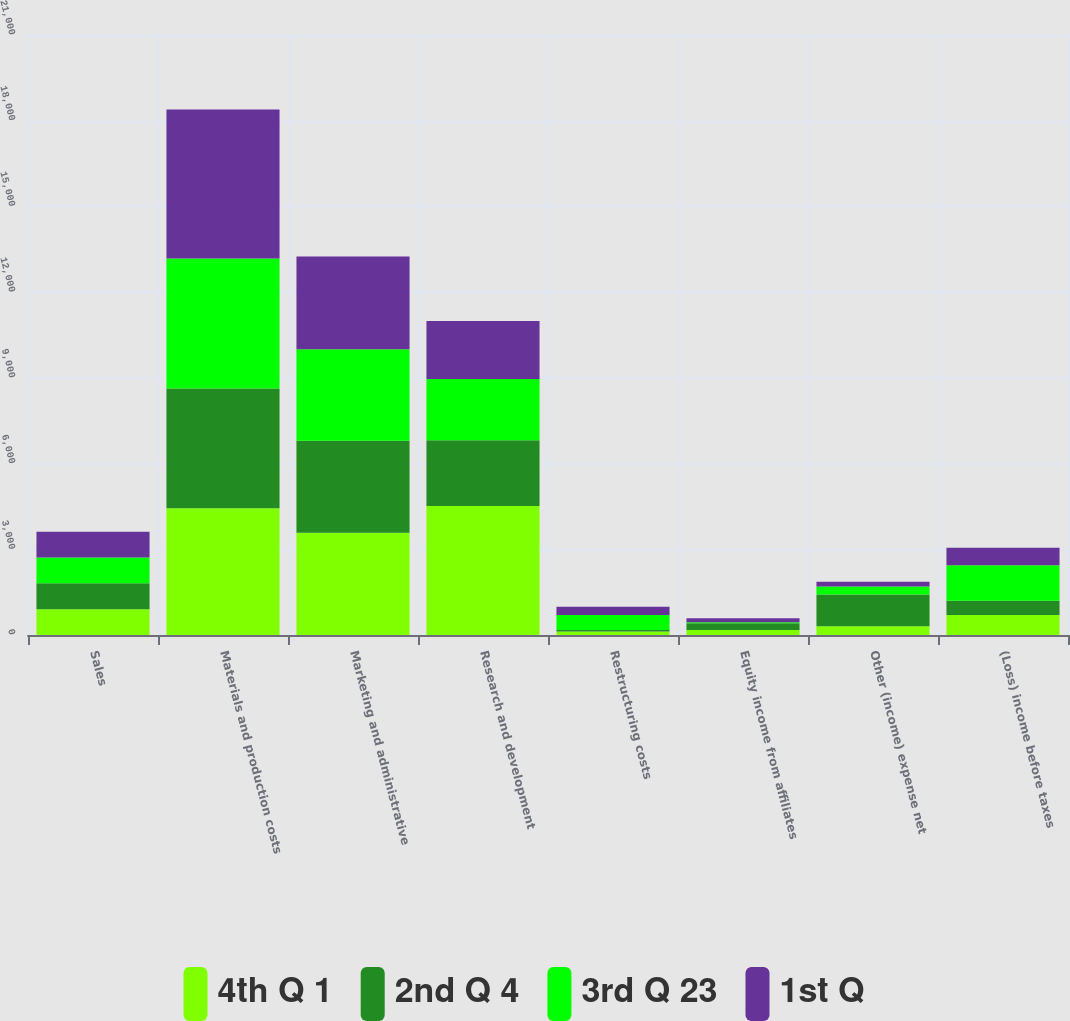<chart> <loc_0><loc_0><loc_500><loc_500><stacked_bar_chart><ecel><fcel>Sales<fcel>Materials and production costs<fcel>Marketing and administrative<fcel>Research and development<fcel>Restructuring costs<fcel>Equity income from affiliates<fcel>Other (income) expense net<fcel>(Loss) income before taxes<nl><fcel>4th Q 1<fcel>904.5<fcel>4440<fcel>3579<fcel>4517<fcel>121<fcel>171<fcel>309<fcel>701<nl><fcel>2nd Q 4<fcel>904.5<fcel>4191<fcel>3218<fcel>2296<fcel>50<fcel>236<fcel>1108<fcel>498<nl><fcel>3rd Q 23<fcel>904.5<fcel>4549<fcel>3203<fcel>2151<fcel>526<fcel>43<fcel>281<fcel>1241<nl><fcel>1st Q<fcel>904.5<fcel>5216<fcel>3246<fcel>2027<fcel>288<fcel>138<fcel>167<fcel>616<nl></chart> 